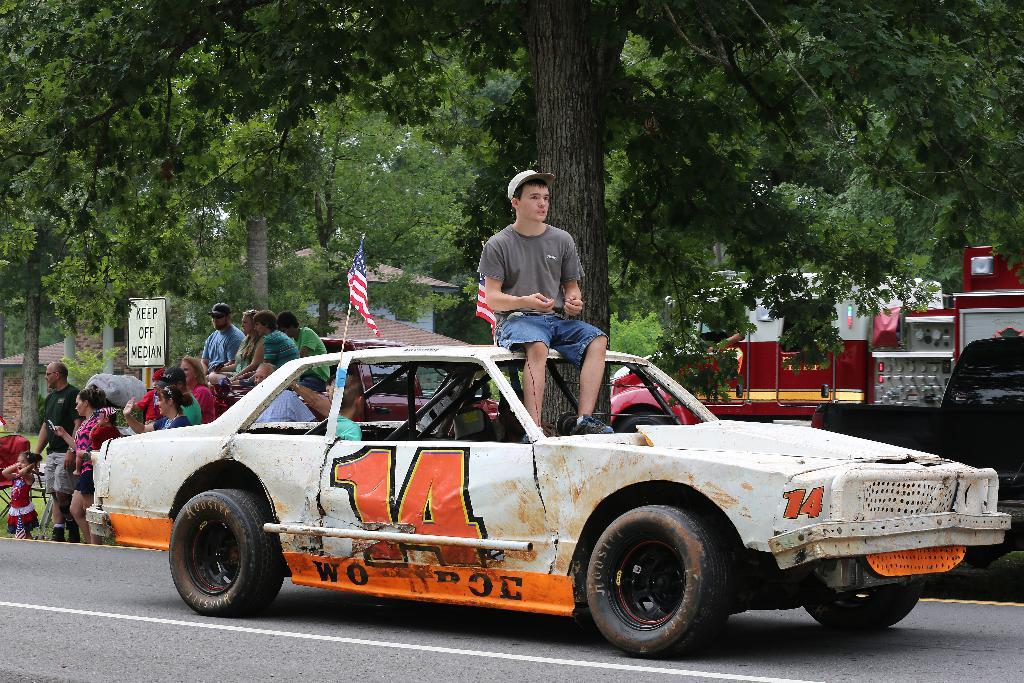What is the man in the image doing? The man is sitting on a car in the image. Where is the car located? The car is on the road in the image. What can be seen in the background of the image? There are trees, flags, vehicles, and people in the background. Is there any signage visible in the background? Yes, there is a name board in the background. What type of paper is the man using to paint the kittens in the image? There is no paper, paint, or kittens present in the image. 